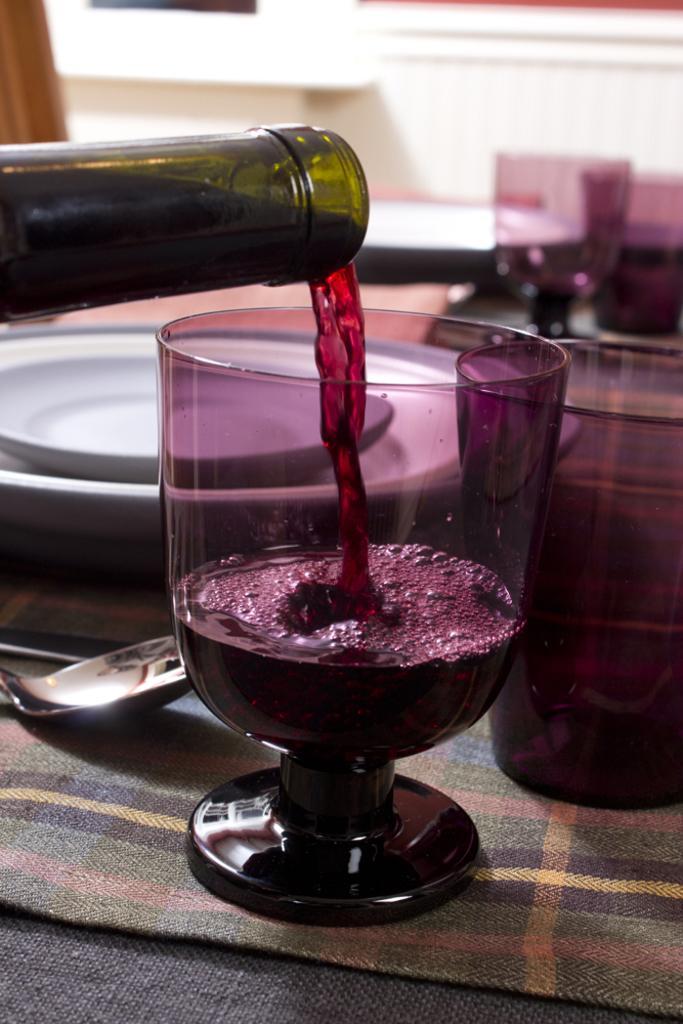In one or two sentences, can you explain what this image depicts? Here we can see a glass on the table, and plates,spoons, and bottle and some other objects on it. 